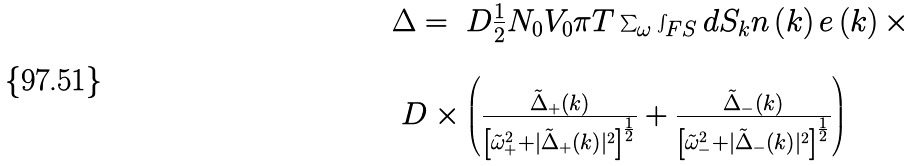<formula> <loc_0><loc_0><loc_500><loc_500>\begin{array} { l } \Delta = \ D \frac { 1 } { 2 } N _ { 0 } V _ { 0 } \pi T \sum _ { \omega } \int _ { F S } d S _ { k } n \left ( { k } \right ) e \left ( { k } \right ) \times \\ \\ \ D \times \left ( \frac { \tilde { \Delta } _ { + } \left ( { k } \right ) } { \left [ \tilde { \omega } _ { + } ^ { 2 } + | \tilde { \Delta } _ { + } \left ( { k } \right ) | ^ { 2 } \right ] ^ { \frac { 1 } { 2 } } } + \frac { \tilde { \Delta } _ { - } \left ( { k } \right ) } { \left [ \tilde { \omega } _ { - } ^ { 2 } + | \tilde { \Delta } _ { - } \left ( { k } \right ) | ^ { 2 } \right ] ^ { \frac { 1 } { 2 } } } \right ) \end{array}</formula> 